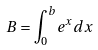Convert formula to latex. <formula><loc_0><loc_0><loc_500><loc_500>B = \int _ { 0 } ^ { b } e ^ { x } d x</formula> 